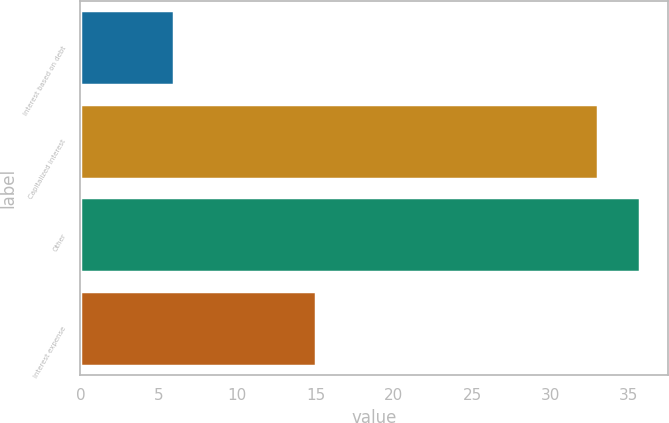<chart> <loc_0><loc_0><loc_500><loc_500><bar_chart><fcel>Interest based on debt<fcel>Capitalized interest<fcel>Other<fcel>Interest expense<nl><fcel>6<fcel>33<fcel>35.7<fcel>15<nl></chart> 